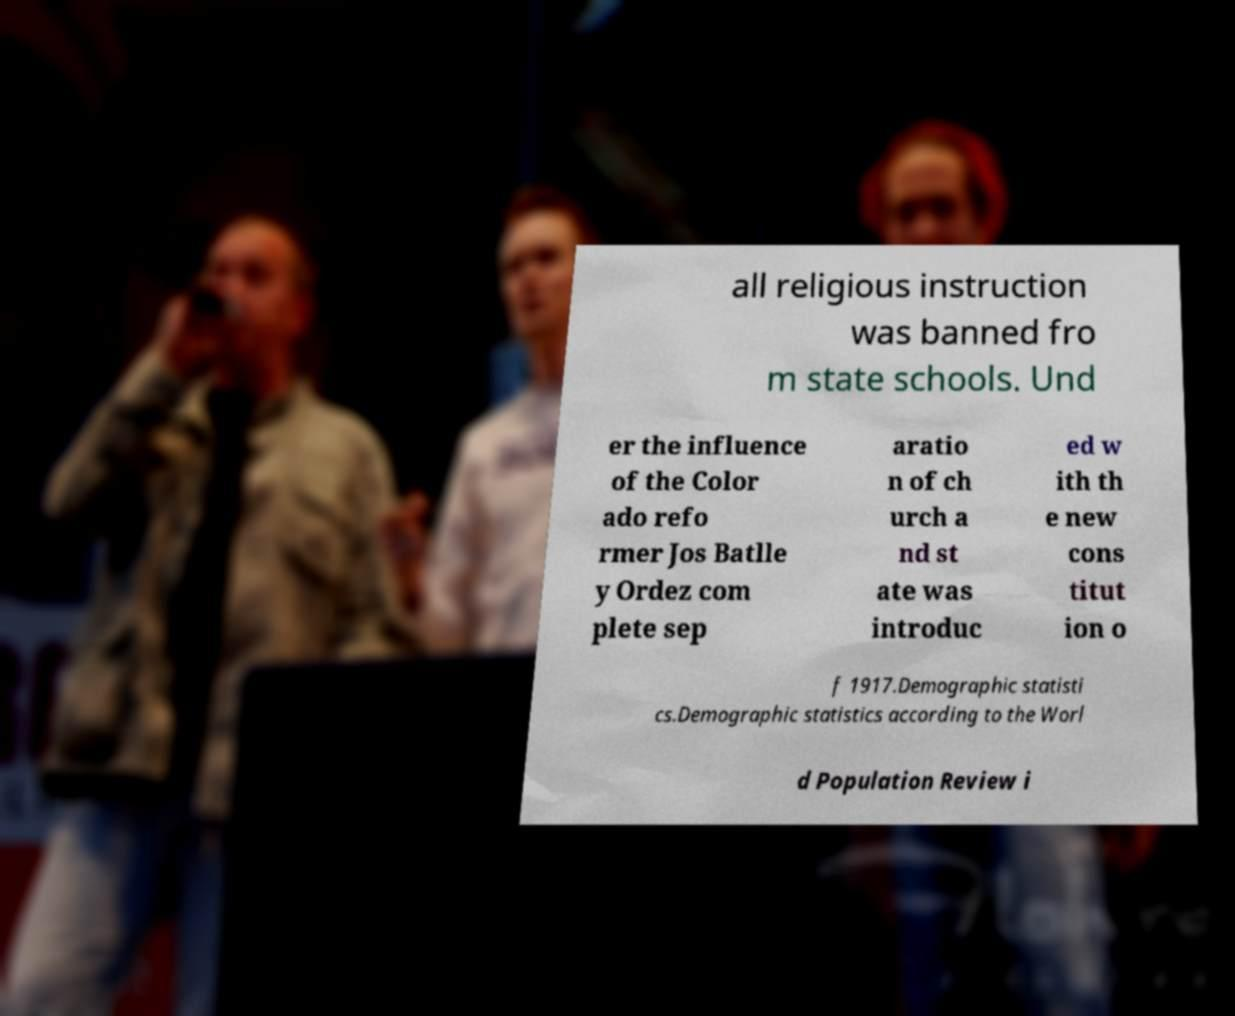For documentation purposes, I need the text within this image transcribed. Could you provide that? all religious instruction was banned fro m state schools. Und er the influence of the Color ado refo rmer Jos Batlle y Ordez com plete sep aratio n of ch urch a nd st ate was introduc ed w ith th e new cons titut ion o f 1917.Demographic statisti cs.Demographic statistics according to the Worl d Population Review i 